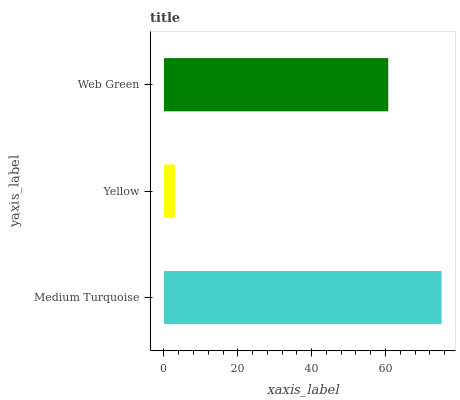Is Yellow the minimum?
Answer yes or no. Yes. Is Medium Turquoise the maximum?
Answer yes or no. Yes. Is Web Green the minimum?
Answer yes or no. No. Is Web Green the maximum?
Answer yes or no. No. Is Web Green greater than Yellow?
Answer yes or no. Yes. Is Yellow less than Web Green?
Answer yes or no. Yes. Is Yellow greater than Web Green?
Answer yes or no. No. Is Web Green less than Yellow?
Answer yes or no. No. Is Web Green the high median?
Answer yes or no. Yes. Is Web Green the low median?
Answer yes or no. Yes. Is Yellow the high median?
Answer yes or no. No. Is Yellow the low median?
Answer yes or no. No. 